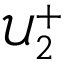Convert formula to latex. <formula><loc_0><loc_0><loc_500><loc_500>\mathcal { U } _ { 2 } ^ { + }</formula> 